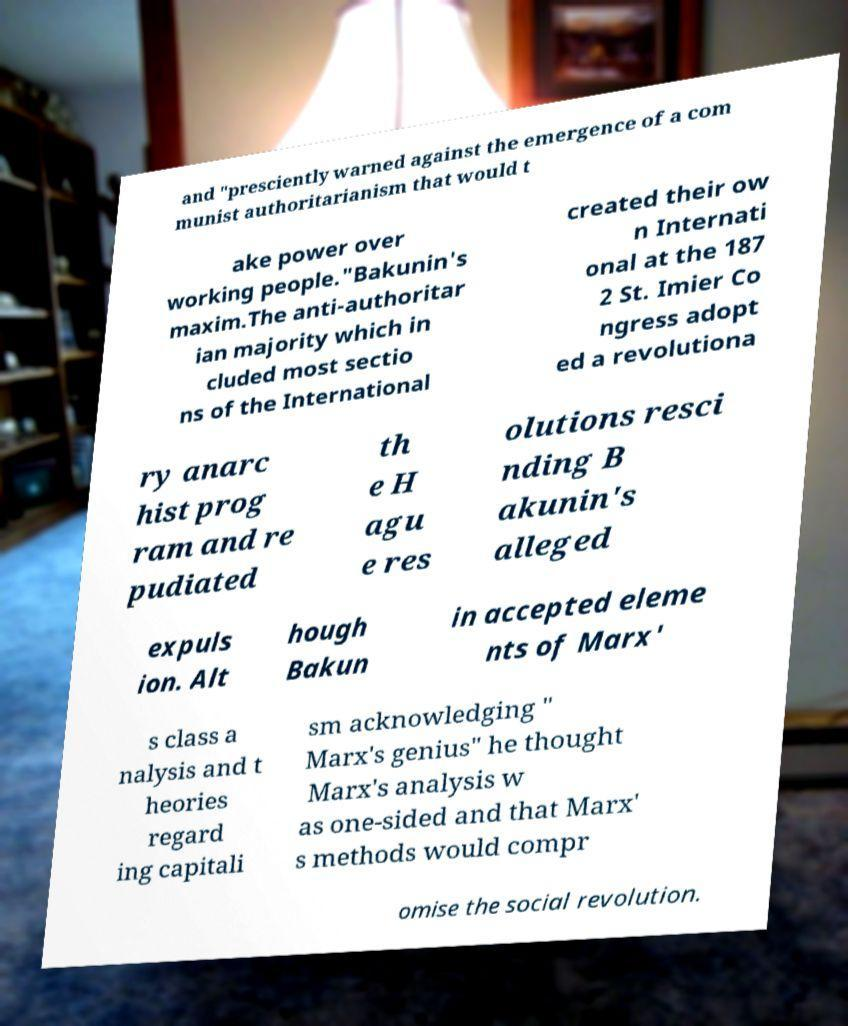What messages or text are displayed in this image? I need them in a readable, typed format. and "presciently warned against the emergence of a com munist authoritarianism that would t ake power over working people."Bakunin's maxim.The anti-authoritar ian majority which in cluded most sectio ns of the International created their ow n Internati onal at the 187 2 St. Imier Co ngress adopt ed a revolutiona ry anarc hist prog ram and re pudiated th e H agu e res olutions resci nding B akunin's alleged expuls ion. Alt hough Bakun in accepted eleme nts of Marx' s class a nalysis and t heories regard ing capitali sm acknowledging " Marx's genius" he thought Marx's analysis w as one-sided and that Marx' s methods would compr omise the social revolution. 